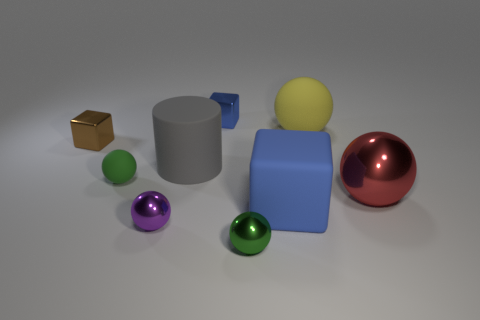In terms of lighting, where do you think the light source is coming from in this image? Observing the shadows and highlights, it seems the primary light source is above and slightly to the right of the scene, creating soft shadows on the left sides of the objects. 